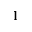<formula> <loc_0><loc_0><loc_500><loc_500>1</formula> 